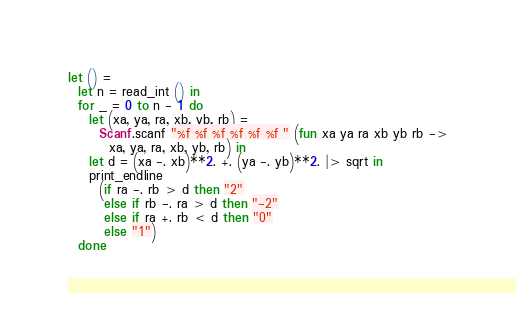Convert code to text. <code><loc_0><loc_0><loc_500><loc_500><_OCaml_>let () =
  let n = read_int () in
  for _ = 0 to n - 1 do
    let (xa, ya, ra, xb, yb, rb) =
      Scanf.scanf "%f %f %f %f %f %f " (fun xa ya ra xb yb rb ->
        xa, ya, ra, xb, yb, rb) in
    let d = (xa -. xb)**2. +. (ya -. yb)**2. |> sqrt in
    print_endline
      (if ra -. rb > d then "2"
       else if rb -. ra > d then "-2"
       else if ra +. rb < d then "0"
       else "1")
  done</code> 